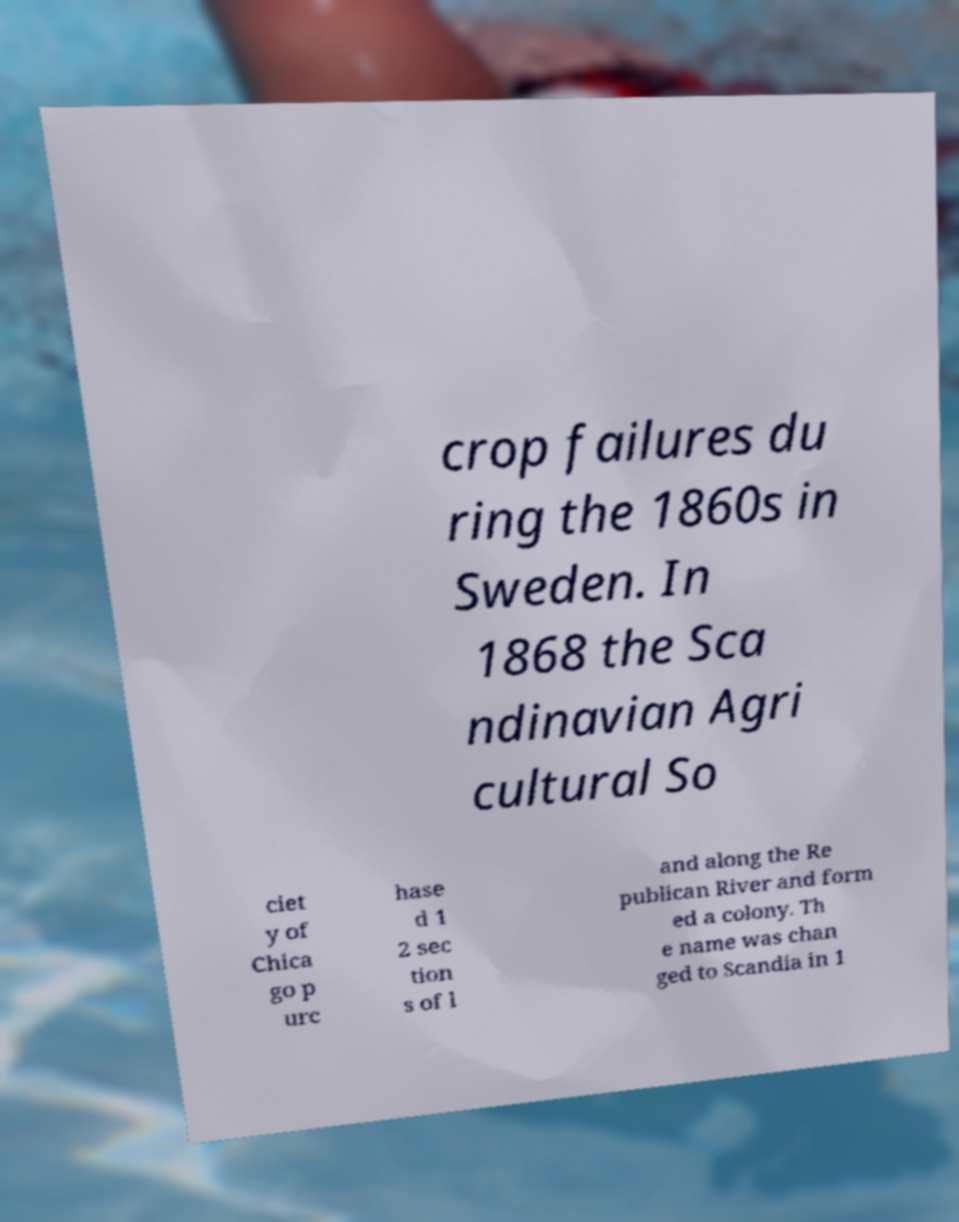I need the written content from this picture converted into text. Can you do that? crop failures du ring the 1860s in Sweden. In 1868 the Sca ndinavian Agri cultural So ciet y of Chica go p urc hase d 1 2 sec tion s of l and along the Re publican River and form ed a colony. Th e name was chan ged to Scandia in 1 